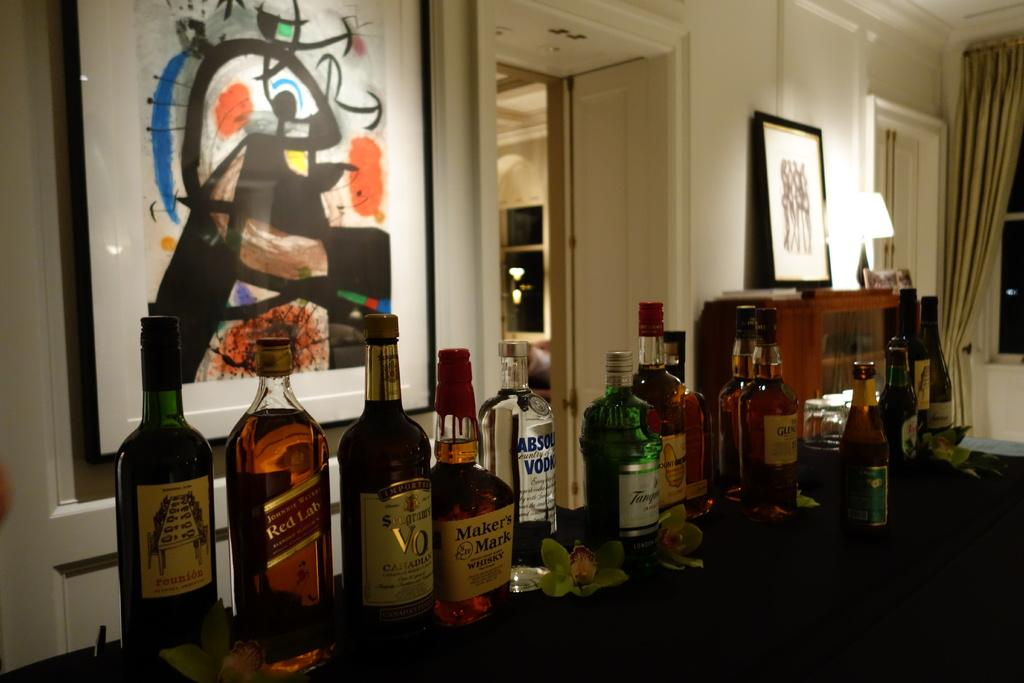<image>
Share a concise interpretation of the image provided. Bar full of alchohol including a bottle of Maker's Mark. 